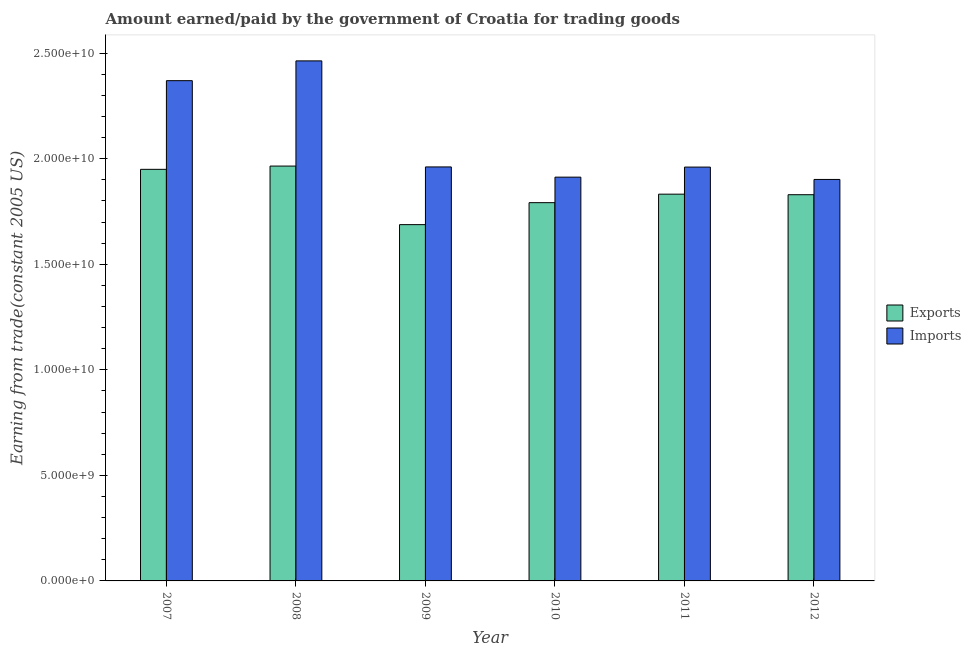How many groups of bars are there?
Provide a short and direct response. 6. What is the label of the 3rd group of bars from the left?
Make the answer very short. 2009. In how many cases, is the number of bars for a given year not equal to the number of legend labels?
Give a very brief answer. 0. What is the amount earned from exports in 2010?
Make the answer very short. 1.79e+1. Across all years, what is the maximum amount earned from exports?
Give a very brief answer. 1.97e+1. Across all years, what is the minimum amount earned from exports?
Make the answer very short. 1.69e+1. What is the total amount earned from exports in the graph?
Offer a terse response. 1.11e+11. What is the difference between the amount earned from exports in 2010 and that in 2012?
Provide a short and direct response. -3.77e+08. What is the difference between the amount earned from exports in 2011 and the amount paid for imports in 2007?
Your answer should be compact. -1.18e+09. What is the average amount earned from exports per year?
Offer a very short reply. 1.84e+1. In the year 2010, what is the difference between the amount paid for imports and amount earned from exports?
Provide a succinct answer. 0. What is the ratio of the amount paid for imports in 2007 to that in 2010?
Provide a succinct answer. 1.24. Is the amount earned from exports in 2007 less than that in 2008?
Keep it short and to the point. Yes. What is the difference between the highest and the second highest amount earned from exports?
Make the answer very short. 1.54e+08. What is the difference between the highest and the lowest amount earned from exports?
Offer a very short reply. 2.77e+09. What does the 1st bar from the left in 2007 represents?
Offer a very short reply. Exports. What does the 1st bar from the right in 2011 represents?
Offer a terse response. Imports. How many bars are there?
Offer a terse response. 12. Are all the bars in the graph horizontal?
Your answer should be very brief. No. What is the difference between two consecutive major ticks on the Y-axis?
Make the answer very short. 5.00e+09. Are the values on the major ticks of Y-axis written in scientific E-notation?
Give a very brief answer. Yes. How are the legend labels stacked?
Make the answer very short. Vertical. What is the title of the graph?
Offer a very short reply. Amount earned/paid by the government of Croatia for trading goods. What is the label or title of the Y-axis?
Ensure brevity in your answer.  Earning from trade(constant 2005 US). What is the Earning from trade(constant 2005 US) in Exports in 2007?
Offer a terse response. 1.95e+1. What is the Earning from trade(constant 2005 US) in Imports in 2007?
Offer a very short reply. 2.37e+1. What is the Earning from trade(constant 2005 US) in Exports in 2008?
Make the answer very short. 1.97e+1. What is the Earning from trade(constant 2005 US) in Imports in 2008?
Give a very brief answer. 2.46e+1. What is the Earning from trade(constant 2005 US) of Exports in 2009?
Provide a succinct answer. 1.69e+1. What is the Earning from trade(constant 2005 US) of Imports in 2009?
Provide a succinct answer. 1.96e+1. What is the Earning from trade(constant 2005 US) in Exports in 2010?
Make the answer very short. 1.79e+1. What is the Earning from trade(constant 2005 US) of Imports in 2010?
Keep it short and to the point. 1.91e+1. What is the Earning from trade(constant 2005 US) in Exports in 2011?
Keep it short and to the point. 1.83e+1. What is the Earning from trade(constant 2005 US) in Imports in 2011?
Give a very brief answer. 1.96e+1. What is the Earning from trade(constant 2005 US) in Exports in 2012?
Provide a succinct answer. 1.83e+1. What is the Earning from trade(constant 2005 US) in Imports in 2012?
Give a very brief answer. 1.90e+1. Across all years, what is the maximum Earning from trade(constant 2005 US) in Exports?
Offer a very short reply. 1.97e+1. Across all years, what is the maximum Earning from trade(constant 2005 US) of Imports?
Ensure brevity in your answer.  2.46e+1. Across all years, what is the minimum Earning from trade(constant 2005 US) in Exports?
Offer a very short reply. 1.69e+1. Across all years, what is the minimum Earning from trade(constant 2005 US) of Imports?
Your answer should be compact. 1.90e+1. What is the total Earning from trade(constant 2005 US) in Exports in the graph?
Offer a very short reply. 1.11e+11. What is the total Earning from trade(constant 2005 US) of Imports in the graph?
Your response must be concise. 1.26e+11. What is the difference between the Earning from trade(constant 2005 US) in Exports in 2007 and that in 2008?
Keep it short and to the point. -1.54e+08. What is the difference between the Earning from trade(constant 2005 US) in Imports in 2007 and that in 2008?
Provide a short and direct response. -9.38e+08. What is the difference between the Earning from trade(constant 2005 US) in Exports in 2007 and that in 2009?
Ensure brevity in your answer.  2.62e+09. What is the difference between the Earning from trade(constant 2005 US) in Imports in 2007 and that in 2009?
Make the answer very short. 4.09e+09. What is the difference between the Earning from trade(constant 2005 US) of Exports in 2007 and that in 2010?
Your answer should be very brief. 1.58e+09. What is the difference between the Earning from trade(constant 2005 US) of Imports in 2007 and that in 2010?
Give a very brief answer. 4.57e+09. What is the difference between the Earning from trade(constant 2005 US) in Exports in 2007 and that in 2011?
Give a very brief answer. 1.18e+09. What is the difference between the Earning from trade(constant 2005 US) in Imports in 2007 and that in 2011?
Give a very brief answer. 4.09e+09. What is the difference between the Earning from trade(constant 2005 US) in Exports in 2007 and that in 2012?
Offer a terse response. 1.20e+09. What is the difference between the Earning from trade(constant 2005 US) of Imports in 2007 and that in 2012?
Ensure brevity in your answer.  4.68e+09. What is the difference between the Earning from trade(constant 2005 US) of Exports in 2008 and that in 2009?
Provide a succinct answer. 2.77e+09. What is the difference between the Earning from trade(constant 2005 US) in Imports in 2008 and that in 2009?
Give a very brief answer. 5.02e+09. What is the difference between the Earning from trade(constant 2005 US) of Exports in 2008 and that in 2010?
Ensure brevity in your answer.  1.73e+09. What is the difference between the Earning from trade(constant 2005 US) of Imports in 2008 and that in 2010?
Provide a succinct answer. 5.51e+09. What is the difference between the Earning from trade(constant 2005 US) in Exports in 2008 and that in 2011?
Your answer should be very brief. 1.33e+09. What is the difference between the Earning from trade(constant 2005 US) in Imports in 2008 and that in 2011?
Your answer should be very brief. 5.03e+09. What is the difference between the Earning from trade(constant 2005 US) of Exports in 2008 and that in 2012?
Offer a terse response. 1.36e+09. What is the difference between the Earning from trade(constant 2005 US) of Imports in 2008 and that in 2012?
Your answer should be compact. 5.62e+09. What is the difference between the Earning from trade(constant 2005 US) of Exports in 2009 and that in 2010?
Ensure brevity in your answer.  -1.04e+09. What is the difference between the Earning from trade(constant 2005 US) in Imports in 2009 and that in 2010?
Your answer should be compact. 4.84e+08. What is the difference between the Earning from trade(constant 2005 US) of Exports in 2009 and that in 2011?
Offer a terse response. -1.44e+09. What is the difference between the Earning from trade(constant 2005 US) of Imports in 2009 and that in 2011?
Ensure brevity in your answer.  7.94e+06. What is the difference between the Earning from trade(constant 2005 US) of Exports in 2009 and that in 2012?
Give a very brief answer. -1.42e+09. What is the difference between the Earning from trade(constant 2005 US) of Imports in 2009 and that in 2012?
Keep it short and to the point. 5.93e+08. What is the difference between the Earning from trade(constant 2005 US) in Exports in 2010 and that in 2011?
Provide a short and direct response. -4.03e+08. What is the difference between the Earning from trade(constant 2005 US) in Imports in 2010 and that in 2011?
Ensure brevity in your answer.  -4.76e+08. What is the difference between the Earning from trade(constant 2005 US) of Exports in 2010 and that in 2012?
Keep it short and to the point. -3.77e+08. What is the difference between the Earning from trade(constant 2005 US) of Imports in 2010 and that in 2012?
Your answer should be very brief. 1.09e+08. What is the difference between the Earning from trade(constant 2005 US) in Exports in 2011 and that in 2012?
Your response must be concise. 2.65e+07. What is the difference between the Earning from trade(constant 2005 US) of Imports in 2011 and that in 2012?
Provide a succinct answer. 5.85e+08. What is the difference between the Earning from trade(constant 2005 US) in Exports in 2007 and the Earning from trade(constant 2005 US) in Imports in 2008?
Your answer should be very brief. -5.14e+09. What is the difference between the Earning from trade(constant 2005 US) of Exports in 2007 and the Earning from trade(constant 2005 US) of Imports in 2009?
Give a very brief answer. -1.14e+08. What is the difference between the Earning from trade(constant 2005 US) of Exports in 2007 and the Earning from trade(constant 2005 US) of Imports in 2010?
Offer a very short reply. 3.70e+08. What is the difference between the Earning from trade(constant 2005 US) in Exports in 2007 and the Earning from trade(constant 2005 US) in Imports in 2011?
Give a very brief answer. -1.06e+08. What is the difference between the Earning from trade(constant 2005 US) in Exports in 2007 and the Earning from trade(constant 2005 US) in Imports in 2012?
Offer a terse response. 4.79e+08. What is the difference between the Earning from trade(constant 2005 US) of Exports in 2008 and the Earning from trade(constant 2005 US) of Imports in 2009?
Keep it short and to the point. 4.00e+07. What is the difference between the Earning from trade(constant 2005 US) of Exports in 2008 and the Earning from trade(constant 2005 US) of Imports in 2010?
Your answer should be compact. 5.24e+08. What is the difference between the Earning from trade(constant 2005 US) in Exports in 2008 and the Earning from trade(constant 2005 US) in Imports in 2011?
Provide a succinct answer. 4.80e+07. What is the difference between the Earning from trade(constant 2005 US) of Exports in 2008 and the Earning from trade(constant 2005 US) of Imports in 2012?
Your answer should be compact. 6.33e+08. What is the difference between the Earning from trade(constant 2005 US) in Exports in 2009 and the Earning from trade(constant 2005 US) in Imports in 2010?
Make the answer very short. -2.25e+09. What is the difference between the Earning from trade(constant 2005 US) in Exports in 2009 and the Earning from trade(constant 2005 US) in Imports in 2011?
Give a very brief answer. -2.73e+09. What is the difference between the Earning from trade(constant 2005 US) of Exports in 2009 and the Earning from trade(constant 2005 US) of Imports in 2012?
Give a very brief answer. -2.14e+09. What is the difference between the Earning from trade(constant 2005 US) in Exports in 2010 and the Earning from trade(constant 2005 US) in Imports in 2011?
Offer a terse response. -1.69e+09. What is the difference between the Earning from trade(constant 2005 US) in Exports in 2010 and the Earning from trade(constant 2005 US) in Imports in 2012?
Your answer should be compact. -1.10e+09. What is the difference between the Earning from trade(constant 2005 US) of Exports in 2011 and the Earning from trade(constant 2005 US) of Imports in 2012?
Your answer should be compact. -6.97e+08. What is the average Earning from trade(constant 2005 US) of Exports per year?
Ensure brevity in your answer.  1.84e+1. What is the average Earning from trade(constant 2005 US) in Imports per year?
Your answer should be very brief. 2.09e+1. In the year 2007, what is the difference between the Earning from trade(constant 2005 US) in Exports and Earning from trade(constant 2005 US) in Imports?
Keep it short and to the point. -4.20e+09. In the year 2008, what is the difference between the Earning from trade(constant 2005 US) of Exports and Earning from trade(constant 2005 US) of Imports?
Ensure brevity in your answer.  -4.98e+09. In the year 2009, what is the difference between the Earning from trade(constant 2005 US) in Exports and Earning from trade(constant 2005 US) in Imports?
Provide a succinct answer. -2.73e+09. In the year 2010, what is the difference between the Earning from trade(constant 2005 US) in Exports and Earning from trade(constant 2005 US) in Imports?
Provide a succinct answer. -1.21e+09. In the year 2011, what is the difference between the Earning from trade(constant 2005 US) of Exports and Earning from trade(constant 2005 US) of Imports?
Give a very brief answer. -1.28e+09. In the year 2012, what is the difference between the Earning from trade(constant 2005 US) of Exports and Earning from trade(constant 2005 US) of Imports?
Your answer should be very brief. -7.24e+08. What is the ratio of the Earning from trade(constant 2005 US) of Exports in 2007 to that in 2008?
Offer a terse response. 0.99. What is the ratio of the Earning from trade(constant 2005 US) of Imports in 2007 to that in 2008?
Offer a terse response. 0.96. What is the ratio of the Earning from trade(constant 2005 US) in Exports in 2007 to that in 2009?
Make the answer very short. 1.16. What is the ratio of the Earning from trade(constant 2005 US) of Imports in 2007 to that in 2009?
Your response must be concise. 1.21. What is the ratio of the Earning from trade(constant 2005 US) of Exports in 2007 to that in 2010?
Offer a very short reply. 1.09. What is the ratio of the Earning from trade(constant 2005 US) in Imports in 2007 to that in 2010?
Provide a succinct answer. 1.24. What is the ratio of the Earning from trade(constant 2005 US) of Exports in 2007 to that in 2011?
Your response must be concise. 1.06. What is the ratio of the Earning from trade(constant 2005 US) of Imports in 2007 to that in 2011?
Provide a short and direct response. 1.21. What is the ratio of the Earning from trade(constant 2005 US) in Exports in 2007 to that in 2012?
Ensure brevity in your answer.  1.07. What is the ratio of the Earning from trade(constant 2005 US) of Imports in 2007 to that in 2012?
Give a very brief answer. 1.25. What is the ratio of the Earning from trade(constant 2005 US) in Exports in 2008 to that in 2009?
Your answer should be compact. 1.16. What is the ratio of the Earning from trade(constant 2005 US) of Imports in 2008 to that in 2009?
Your answer should be very brief. 1.26. What is the ratio of the Earning from trade(constant 2005 US) in Exports in 2008 to that in 2010?
Your answer should be very brief. 1.1. What is the ratio of the Earning from trade(constant 2005 US) of Imports in 2008 to that in 2010?
Provide a short and direct response. 1.29. What is the ratio of the Earning from trade(constant 2005 US) of Exports in 2008 to that in 2011?
Offer a very short reply. 1.07. What is the ratio of the Earning from trade(constant 2005 US) in Imports in 2008 to that in 2011?
Make the answer very short. 1.26. What is the ratio of the Earning from trade(constant 2005 US) in Exports in 2008 to that in 2012?
Your answer should be compact. 1.07. What is the ratio of the Earning from trade(constant 2005 US) in Imports in 2008 to that in 2012?
Your answer should be compact. 1.3. What is the ratio of the Earning from trade(constant 2005 US) in Exports in 2009 to that in 2010?
Your answer should be very brief. 0.94. What is the ratio of the Earning from trade(constant 2005 US) of Imports in 2009 to that in 2010?
Provide a short and direct response. 1.03. What is the ratio of the Earning from trade(constant 2005 US) in Exports in 2009 to that in 2011?
Your response must be concise. 0.92. What is the ratio of the Earning from trade(constant 2005 US) in Exports in 2009 to that in 2012?
Provide a short and direct response. 0.92. What is the ratio of the Earning from trade(constant 2005 US) of Imports in 2009 to that in 2012?
Offer a terse response. 1.03. What is the ratio of the Earning from trade(constant 2005 US) in Imports in 2010 to that in 2011?
Your answer should be very brief. 0.98. What is the ratio of the Earning from trade(constant 2005 US) of Exports in 2010 to that in 2012?
Make the answer very short. 0.98. What is the ratio of the Earning from trade(constant 2005 US) in Imports in 2010 to that in 2012?
Offer a terse response. 1.01. What is the ratio of the Earning from trade(constant 2005 US) of Exports in 2011 to that in 2012?
Offer a terse response. 1. What is the ratio of the Earning from trade(constant 2005 US) of Imports in 2011 to that in 2012?
Give a very brief answer. 1.03. What is the difference between the highest and the second highest Earning from trade(constant 2005 US) of Exports?
Keep it short and to the point. 1.54e+08. What is the difference between the highest and the second highest Earning from trade(constant 2005 US) of Imports?
Ensure brevity in your answer.  9.38e+08. What is the difference between the highest and the lowest Earning from trade(constant 2005 US) in Exports?
Your answer should be very brief. 2.77e+09. What is the difference between the highest and the lowest Earning from trade(constant 2005 US) in Imports?
Ensure brevity in your answer.  5.62e+09. 